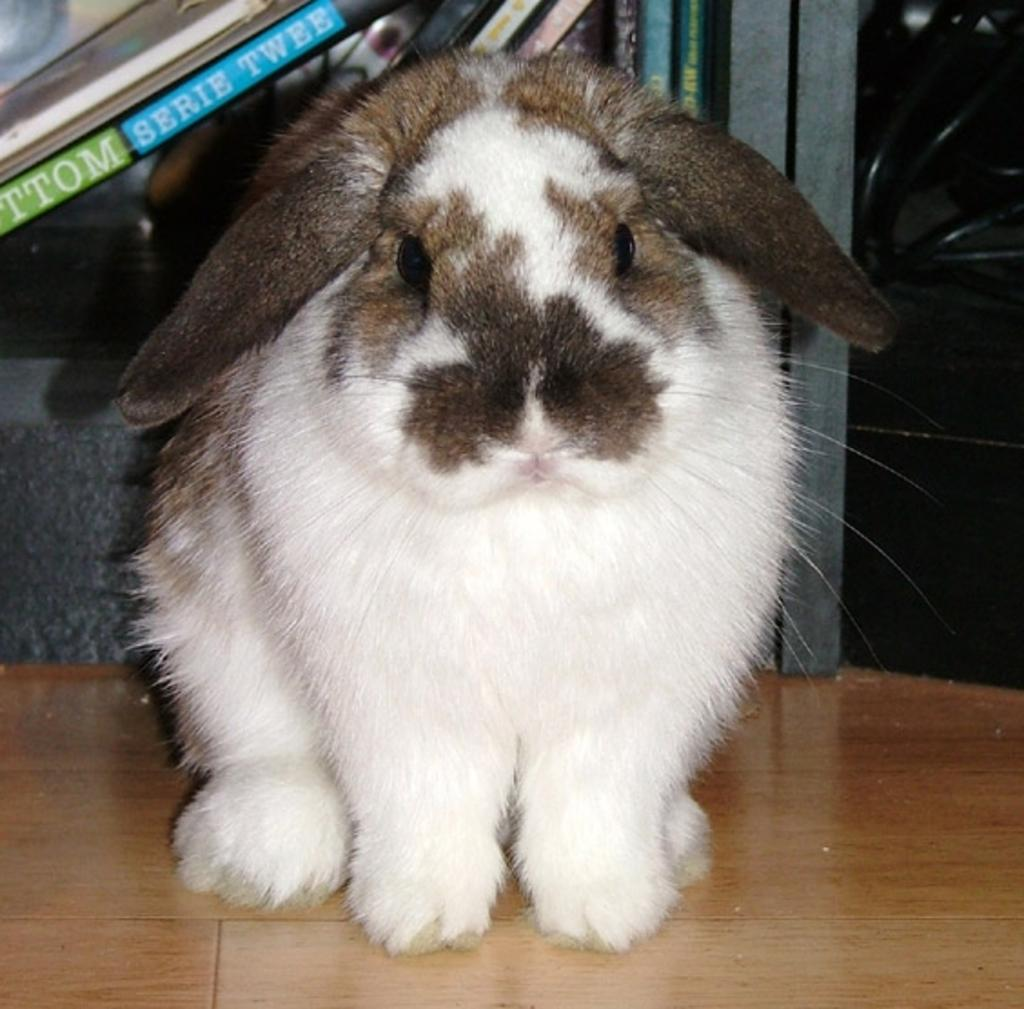What animal is present in the image? There is a white rabbit in the image. Where is the rabbit located in the image? The rabbit is on the floor. What can be seen in the background of the image? There are books in a rack in the background of the image. What type of whip is the rabbit holding in the image? There is no whip present in the image; the rabbit is not holding anything. 